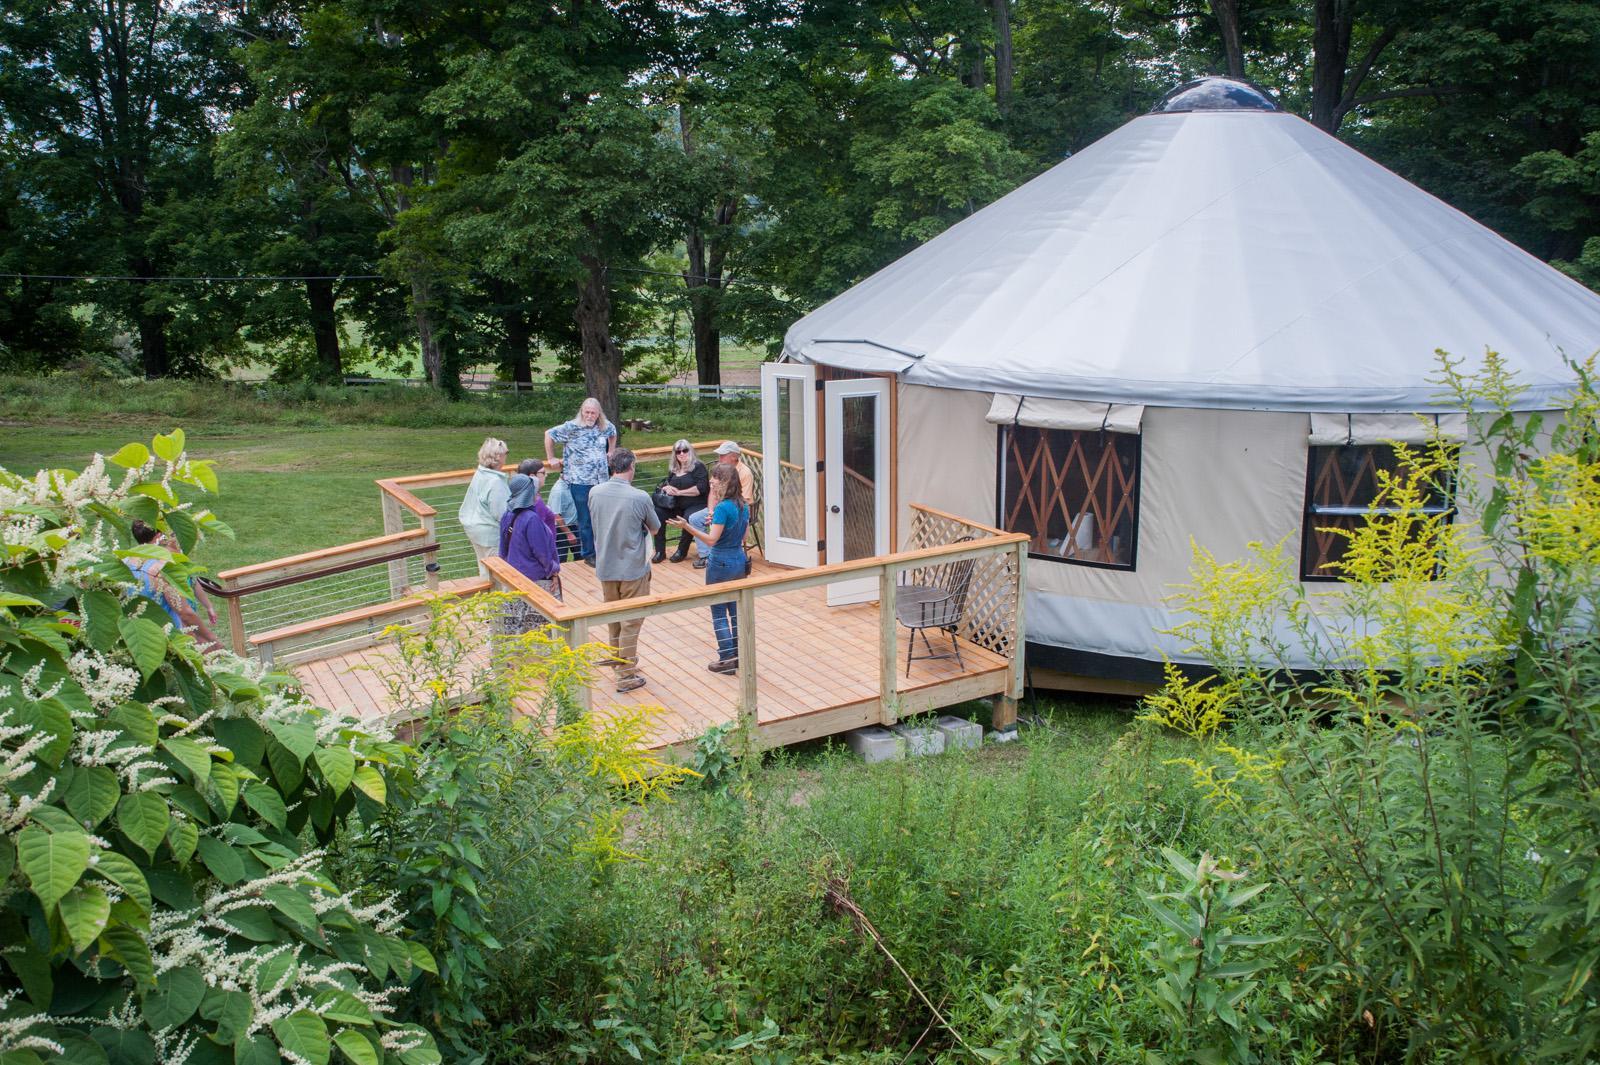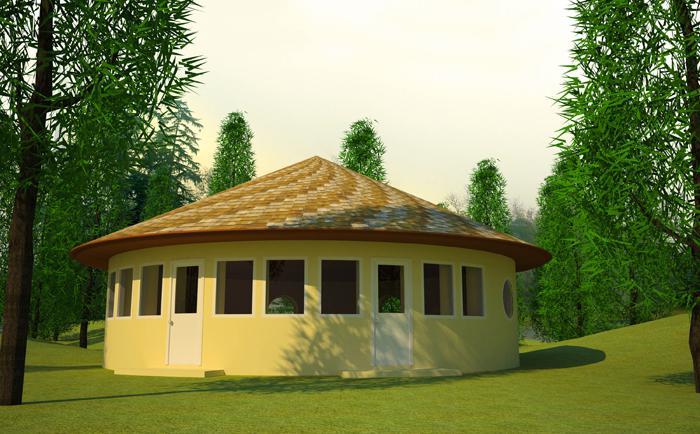The first image is the image on the left, the second image is the image on the right. Given the left and right images, does the statement "One building has green grass growing on its room." hold true? Answer yes or no. No. The first image is the image on the left, the second image is the image on the right. Given the left and right images, does the statement "The structures in the right image have grass on the roof." hold true? Answer yes or no. No. 